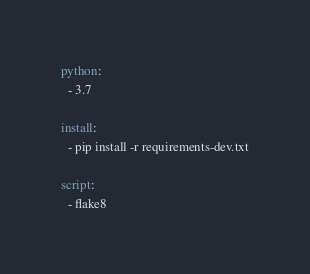Convert code to text. <code><loc_0><loc_0><loc_500><loc_500><_YAML_>
python:
  - 3.7

install:
  - pip install -r requirements-dev.txt

script:
  - flake8
</code> 